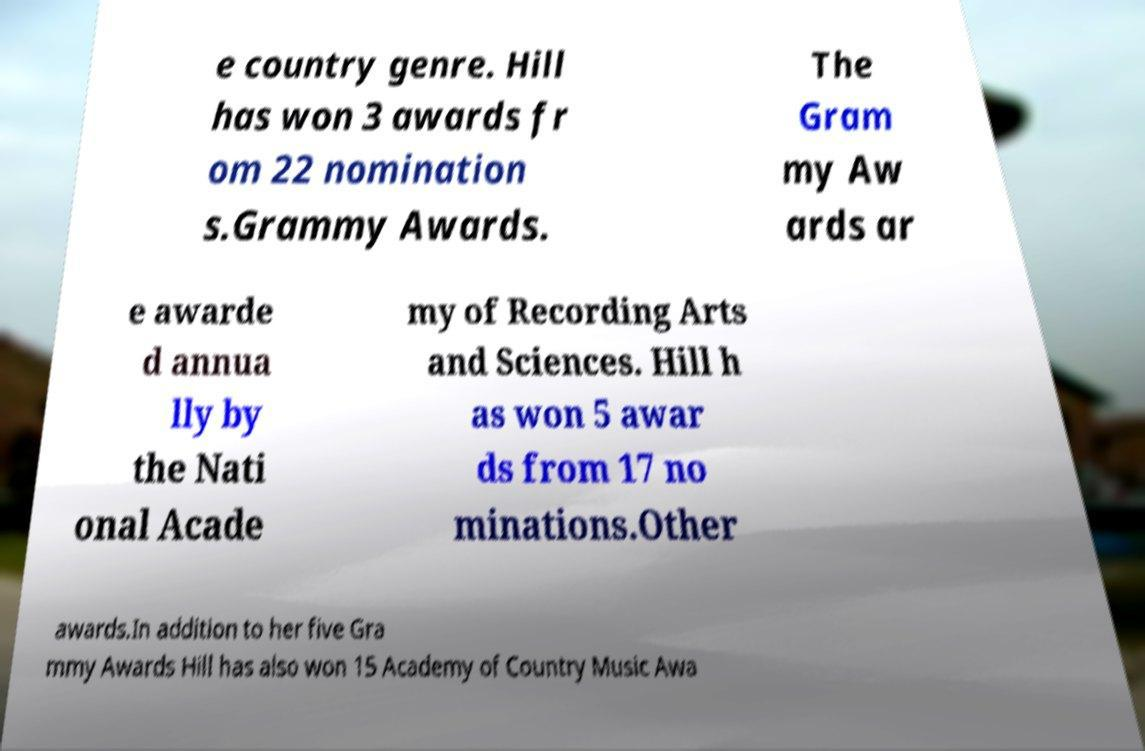There's text embedded in this image that I need extracted. Can you transcribe it verbatim? e country genre. Hill has won 3 awards fr om 22 nomination s.Grammy Awards. The Gram my Aw ards ar e awarde d annua lly by the Nati onal Acade my of Recording Arts and Sciences. Hill h as won 5 awar ds from 17 no minations.Other awards.In addition to her five Gra mmy Awards Hill has also won 15 Academy of Country Music Awa 